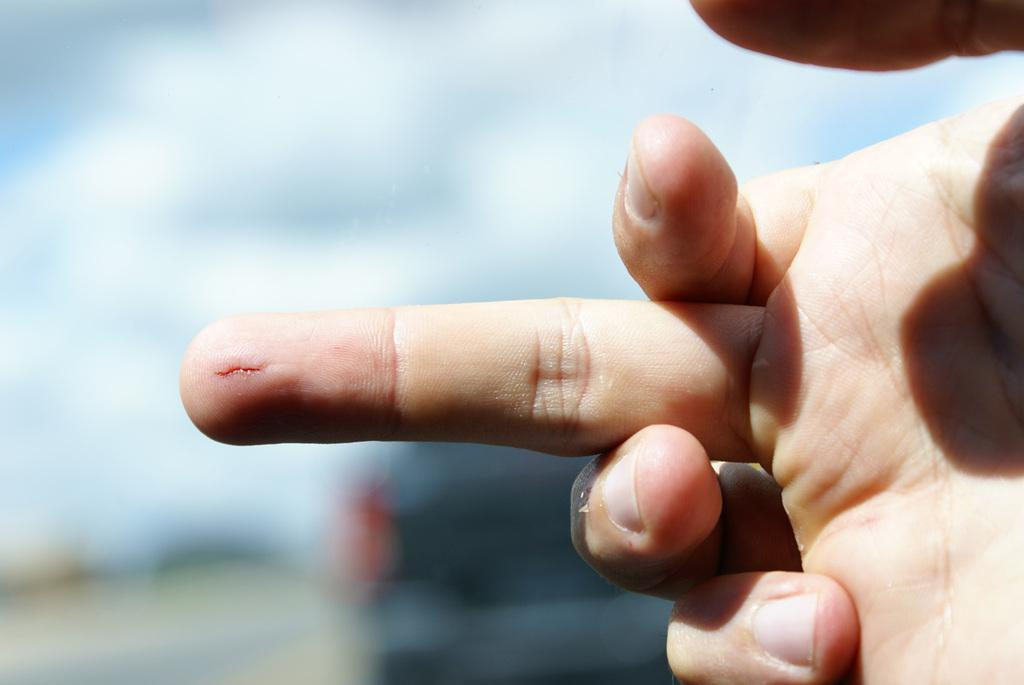What part of a person's body is visible in the image? There is a person's hand in the image. Can you describe any notable features of the hand? There is a cut mark on the finger of the hand. What can be observed about the image's background? The background of the image is blurred. What type of object can be seen in the background? There is a vehicle visible in the background. Which direction is the man facing in the image? There is no man present in the image, only a person's hand with a cut mark on the finger. 